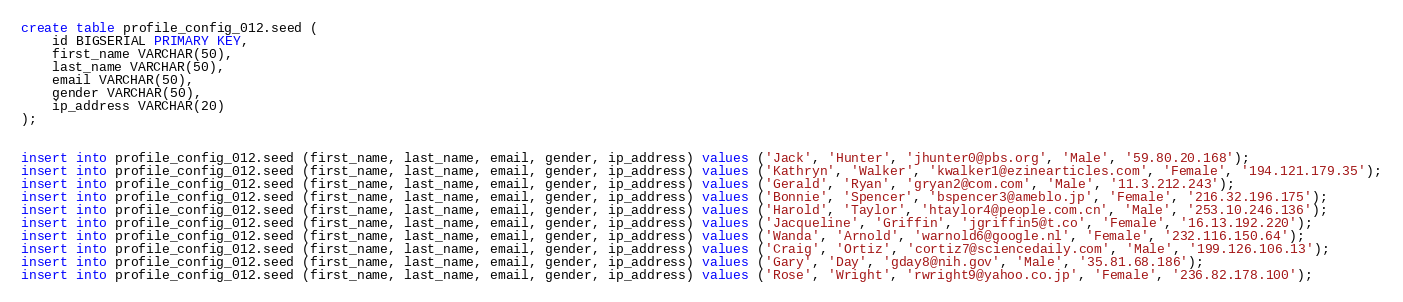<code> <loc_0><loc_0><loc_500><loc_500><_SQL_>create table profile_config_012.seed (
	id BIGSERIAL PRIMARY KEY,
	first_name VARCHAR(50),
	last_name VARCHAR(50),
	email VARCHAR(50),
	gender VARCHAR(50),
	ip_address VARCHAR(20)
);


insert into profile_config_012.seed (first_name, last_name, email, gender, ip_address) values ('Jack', 'Hunter', 'jhunter0@pbs.org', 'Male', '59.80.20.168');
insert into profile_config_012.seed (first_name, last_name, email, gender, ip_address) values ('Kathryn', 'Walker', 'kwalker1@ezinearticles.com', 'Female', '194.121.179.35');
insert into profile_config_012.seed (first_name, last_name, email, gender, ip_address) values ('Gerald', 'Ryan', 'gryan2@com.com', 'Male', '11.3.212.243');
insert into profile_config_012.seed (first_name, last_name, email, gender, ip_address) values ('Bonnie', 'Spencer', 'bspencer3@ameblo.jp', 'Female', '216.32.196.175');
insert into profile_config_012.seed (first_name, last_name, email, gender, ip_address) values ('Harold', 'Taylor', 'htaylor4@people.com.cn', 'Male', '253.10.246.136');
insert into profile_config_012.seed (first_name, last_name, email, gender, ip_address) values ('Jacqueline', 'Griffin', 'jgriffin5@t.co', 'Female', '16.13.192.220');
insert into profile_config_012.seed (first_name, last_name, email, gender, ip_address) values ('Wanda', 'Arnold', 'warnold6@google.nl', 'Female', '232.116.150.64');
insert into profile_config_012.seed (first_name, last_name, email, gender, ip_address) values ('Craig', 'Ortiz', 'cortiz7@sciencedaily.com', 'Male', '199.126.106.13');
insert into profile_config_012.seed (first_name, last_name, email, gender, ip_address) values ('Gary', 'Day', 'gday8@nih.gov', 'Male', '35.81.68.186');
insert into profile_config_012.seed (first_name, last_name, email, gender, ip_address) values ('Rose', 'Wright', 'rwright9@yahoo.co.jp', 'Female', '236.82.178.100');
</code> 